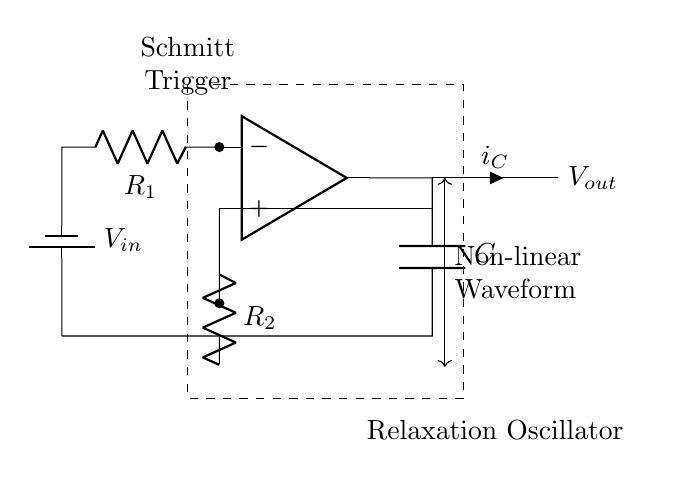What is the type of oscillator depicted in the circuit? The circuit diagram displays a relaxation oscillator, which is commonly characterized by generating non-linear waveforms through the charging and discharging of a capacitor in combination with a comparator like a Schmitt trigger.
Answer: Relaxation oscillator What component controls the timing in the circuit? The timing in the circuit is primarily controlled by the capacitor, as it charges and discharges, determining the frequency of the output waveform in conjunction with the resistors.
Answer: Capacitor What are the resistances present in the circuit? The circuit includes two resistors labeled as R1 and R2. These resistors are integral to the functioning of the Schmitt trigger, influencing the thresholds for switching.
Answer: R1 and R2 What is the output of the circuit referred to as? The output of the oscillator circuit is referred to as Vout, which represents the varying voltage levels produced by the oscillation process as it transitions between high and low states.
Answer: Vout How does the circuit generate a non-linear waveform? The generation of a non-linear waveform occurs due to the charging and discharging actions of the capacitor through the defined resistance network, along with the hysteresis effect implemented by the Schmitt trigger, which causes rapid transitions between voltage states.
Answer: Hysteresis effect What type of trigger is used in this oscillator circuit? The circuit diagram indicates the use of a Schmitt trigger, which is a specific type of comparator characterized by its threshold levels that introduce hysteresis, making it suitable for generating square waves or non-linear waveforms.
Answer: Schmitt trigger What is the role of the battery in the circuit? The battery provides the necessary input voltage (Vin) which powers the circuit, enabling the operation of the Schmitt trigger and the subsequent charge and discharge cycles through the capacitor.
Answer: Power supply 